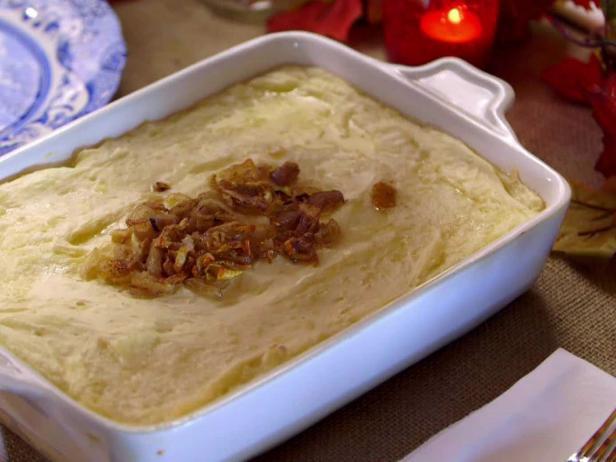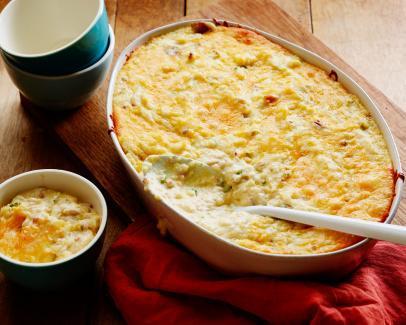The first image is the image on the left, the second image is the image on the right. Given the left and right images, does the statement "There is a utensil sitting in the dish of food in the image on the right." hold true? Answer yes or no. Yes. The first image is the image on the left, the second image is the image on the right. For the images displayed, is the sentence "there is a serving spoon in the disg of potatoes" factually correct? Answer yes or no. Yes. 